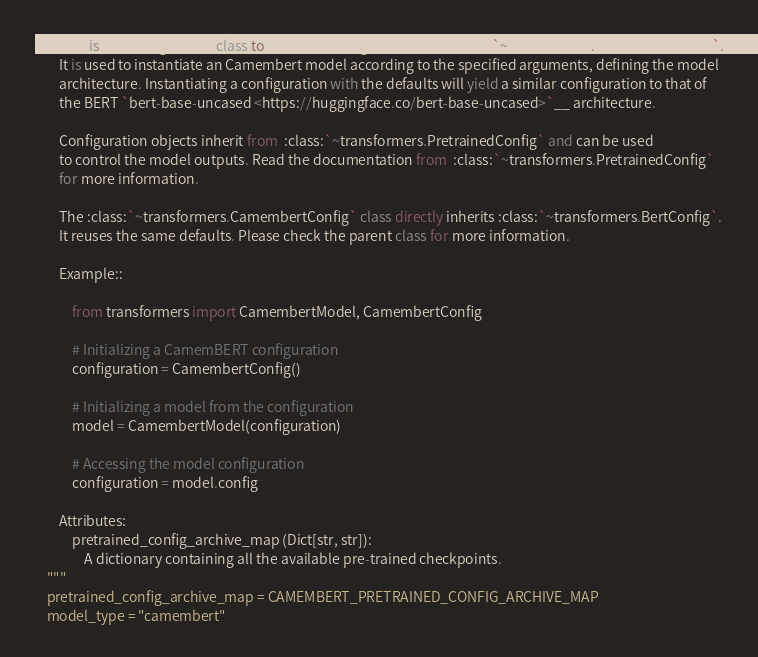<code> <loc_0><loc_0><loc_500><loc_500><_Python_>        This is the configuration class to store the configuration of an :class:`~transformers.CamembertModel`.
        It is used to instantiate an Camembert model according to the specified arguments, defining the model
        architecture. Instantiating a configuration with the defaults will yield a similar configuration to that of
        the BERT `bert-base-uncased <https://huggingface.co/bert-base-uncased>`__ architecture.

        Configuration objects inherit from  :class:`~transformers.PretrainedConfig` and can be used
        to control the model outputs. Read the documentation from  :class:`~transformers.PretrainedConfig`
        for more information.

        The :class:`~transformers.CamembertConfig` class directly inherits :class:`~transformers.BertConfig`.
        It reuses the same defaults. Please check the parent class for more information.

        Example::

            from transformers import CamembertModel, CamembertConfig

            # Initializing a CamemBERT configuration
            configuration = CamembertConfig()

            # Initializing a model from the configuration
            model = CamembertModel(configuration)

            # Accessing the model configuration
            configuration = model.config

        Attributes:
            pretrained_config_archive_map (Dict[str, str]):
                A dictionary containing all the available pre-trained checkpoints.
    """
    pretrained_config_archive_map = CAMEMBERT_PRETRAINED_CONFIG_ARCHIVE_MAP
    model_type = "camembert"
</code> 